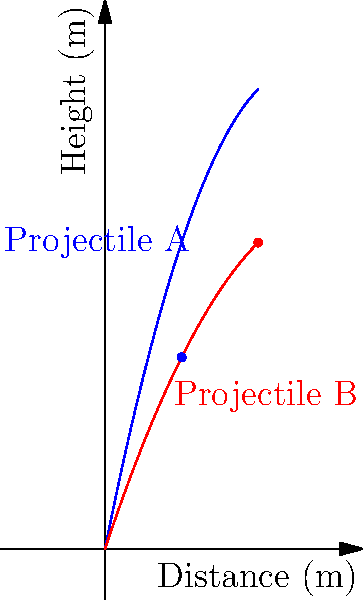In a leadership development program, two teams are tasked with launching projectiles to demonstrate different approaches to problem-solving. Team A launches Projectile A at a steeper angle, while Team B launches Projectile B at a shallower angle. Both projectiles are shown in the graph above, with Projectile A in blue and Projectile B in red. 

If Projectile A reaches its maximum height at 5 meters horizontal distance and Projectile B reaches its maximum height at 10 meters horizontal distance, what is the ratio of the maximum heights reached by Projectile A to Projectile B? To solve this problem, we need to follow these steps:

1. Identify the equations of the trajectories:
   Projectile A: $y = -0.2x^2 + 5x$
   Projectile B: $y = -0.1x^2 + 3x$

2. Find the maximum height for Projectile A:
   - We know it occurs at x = 5 m
   - Substitute x = 5 into the equation for Projectile A:
     $y_A = -0.2(5)^2 + 5(5) = -5 + 25 = 20$ m

3. Find the maximum height for Projectile B:
   - We know it occurs at x = 10 m
   - Substitute x = 10 into the equation for Projectile B:
     $y_B = -0.1(10)^2 + 3(10) = -10 + 30 = 20$ m

4. Calculate the ratio of maximum heights:
   Ratio = $\frac{\text{Max height of A}}{\text{Max height of B}} = \frac{20}{20} = 1$

This result shows that despite the different trajectories and launch angles, both projectiles reach the same maximum height. This could be used as a metaphor for how different leadership styles (represented by the different launch angles) can achieve similar results (maximum height) through different approaches.
Answer: 1:1 